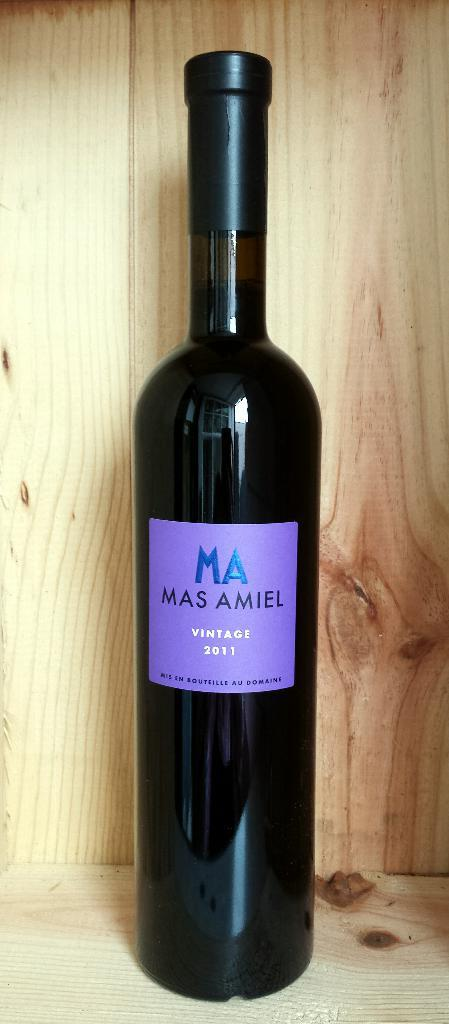<image>
Share a concise interpretation of the image provided. A wine bottle with a purple label says Mas Amiel Vintage 2011. 